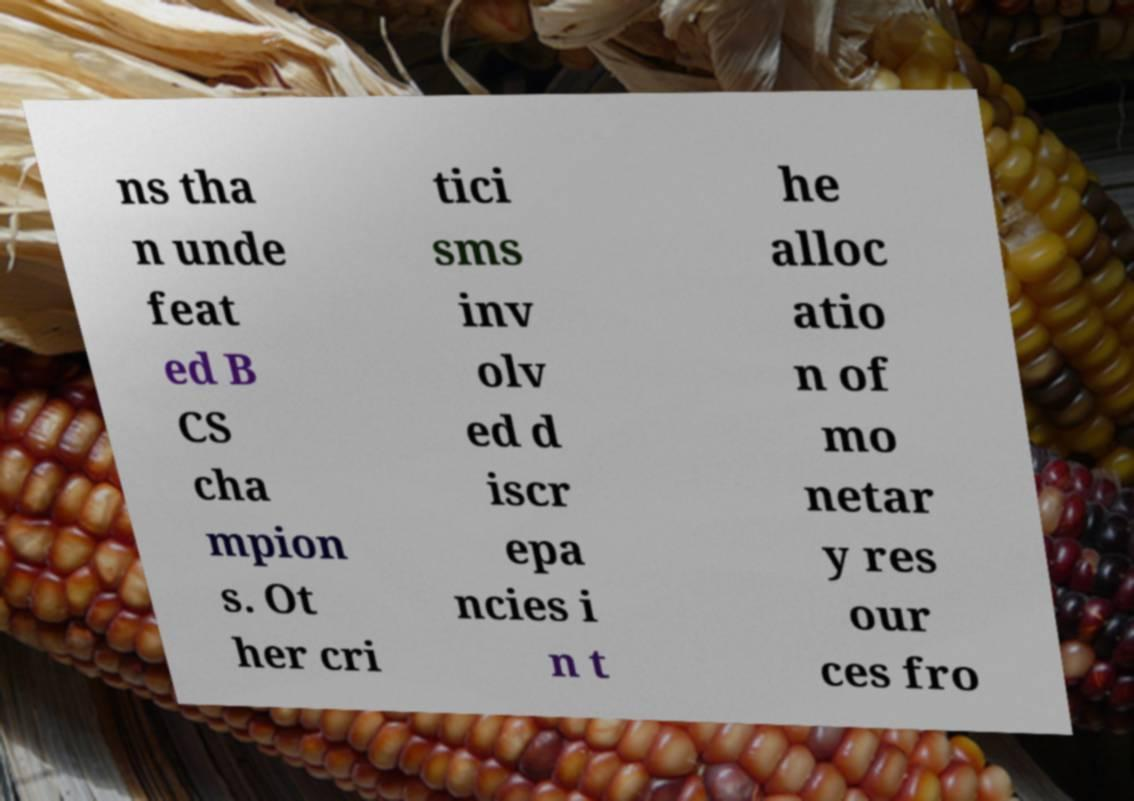Please read and relay the text visible in this image. What does it say? ns tha n unde feat ed B CS cha mpion s. Ot her cri tici sms inv olv ed d iscr epa ncies i n t he alloc atio n of mo netar y res our ces fro 